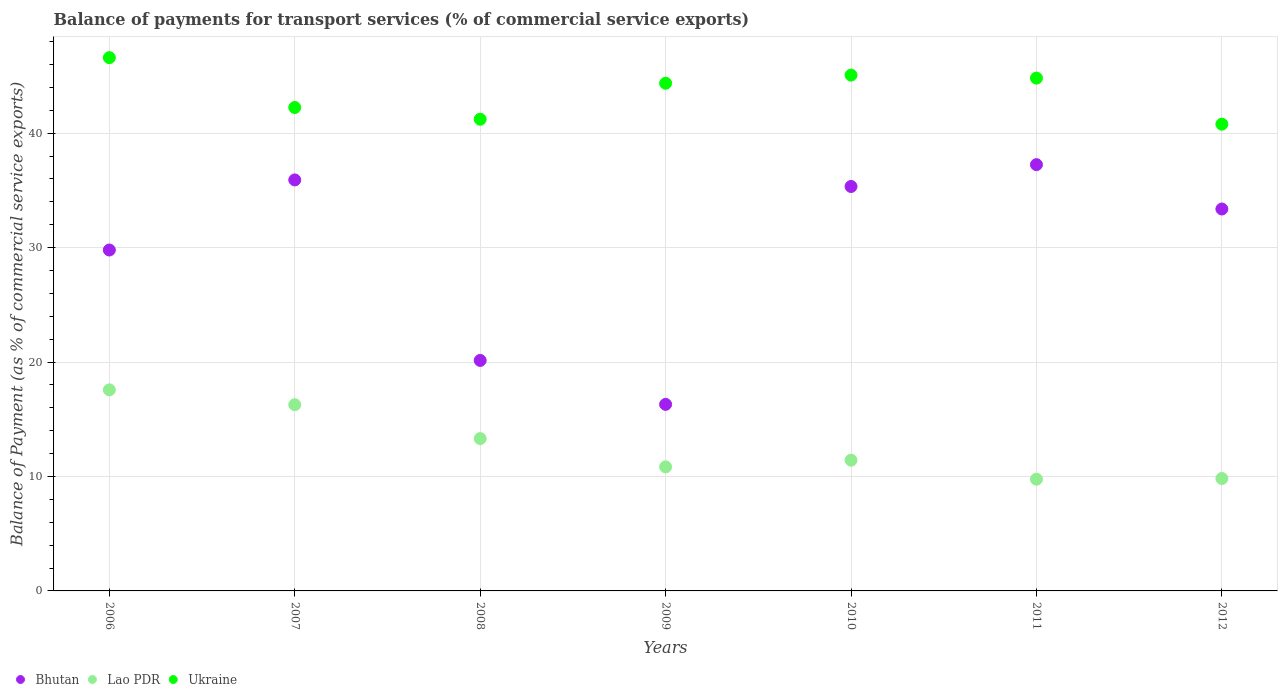Is the number of dotlines equal to the number of legend labels?
Provide a short and direct response. Yes. What is the balance of payments for transport services in Lao PDR in 2012?
Provide a short and direct response. 9.82. Across all years, what is the maximum balance of payments for transport services in Ukraine?
Provide a succinct answer. 46.6. Across all years, what is the minimum balance of payments for transport services in Ukraine?
Provide a short and direct response. 40.79. In which year was the balance of payments for transport services in Lao PDR maximum?
Make the answer very short. 2006. What is the total balance of payments for transport services in Ukraine in the graph?
Give a very brief answer. 305.09. What is the difference between the balance of payments for transport services in Ukraine in 2008 and that in 2009?
Your answer should be very brief. -3.15. What is the difference between the balance of payments for transport services in Ukraine in 2006 and the balance of payments for transport services in Lao PDR in 2009?
Provide a short and direct response. 35.76. What is the average balance of payments for transport services in Bhutan per year?
Your response must be concise. 29.73. In the year 2010, what is the difference between the balance of payments for transport services in Bhutan and balance of payments for transport services in Ukraine?
Provide a succinct answer. -9.73. What is the ratio of the balance of payments for transport services in Bhutan in 2006 to that in 2009?
Your answer should be compact. 1.83. Is the difference between the balance of payments for transport services in Bhutan in 2006 and 2010 greater than the difference between the balance of payments for transport services in Ukraine in 2006 and 2010?
Provide a succinct answer. No. What is the difference between the highest and the second highest balance of payments for transport services in Bhutan?
Give a very brief answer. 1.33. What is the difference between the highest and the lowest balance of payments for transport services in Bhutan?
Your response must be concise. 20.95. Is it the case that in every year, the sum of the balance of payments for transport services in Bhutan and balance of payments for transport services in Lao PDR  is greater than the balance of payments for transport services in Ukraine?
Offer a very short reply. No. What is the difference between two consecutive major ticks on the Y-axis?
Provide a short and direct response. 10. Does the graph contain grids?
Your response must be concise. Yes. How many legend labels are there?
Your response must be concise. 3. What is the title of the graph?
Your answer should be compact. Balance of payments for transport services (% of commercial service exports). Does "Fragile and conflict affected situations" appear as one of the legend labels in the graph?
Give a very brief answer. No. What is the label or title of the Y-axis?
Keep it short and to the point. Balance of Payment (as % of commercial service exports). What is the Balance of Payment (as % of commercial service exports) in Bhutan in 2006?
Make the answer very short. 29.79. What is the Balance of Payment (as % of commercial service exports) of Lao PDR in 2006?
Give a very brief answer. 17.57. What is the Balance of Payment (as % of commercial service exports) in Ukraine in 2006?
Your response must be concise. 46.6. What is the Balance of Payment (as % of commercial service exports) in Bhutan in 2007?
Offer a very short reply. 35.91. What is the Balance of Payment (as % of commercial service exports) of Lao PDR in 2007?
Give a very brief answer. 16.27. What is the Balance of Payment (as % of commercial service exports) of Ukraine in 2007?
Provide a short and direct response. 42.24. What is the Balance of Payment (as % of commercial service exports) of Bhutan in 2008?
Give a very brief answer. 20.14. What is the Balance of Payment (as % of commercial service exports) in Lao PDR in 2008?
Give a very brief answer. 13.31. What is the Balance of Payment (as % of commercial service exports) of Ukraine in 2008?
Offer a terse response. 41.22. What is the Balance of Payment (as % of commercial service exports) in Bhutan in 2009?
Your answer should be very brief. 16.3. What is the Balance of Payment (as % of commercial service exports) of Lao PDR in 2009?
Your answer should be very brief. 10.84. What is the Balance of Payment (as % of commercial service exports) of Ukraine in 2009?
Ensure brevity in your answer.  44.36. What is the Balance of Payment (as % of commercial service exports) of Bhutan in 2010?
Your response must be concise. 35.34. What is the Balance of Payment (as % of commercial service exports) of Lao PDR in 2010?
Ensure brevity in your answer.  11.42. What is the Balance of Payment (as % of commercial service exports) in Ukraine in 2010?
Your response must be concise. 45.07. What is the Balance of Payment (as % of commercial service exports) of Bhutan in 2011?
Offer a very short reply. 37.25. What is the Balance of Payment (as % of commercial service exports) of Lao PDR in 2011?
Your response must be concise. 9.76. What is the Balance of Payment (as % of commercial service exports) of Ukraine in 2011?
Keep it short and to the point. 44.81. What is the Balance of Payment (as % of commercial service exports) of Bhutan in 2012?
Your answer should be very brief. 33.37. What is the Balance of Payment (as % of commercial service exports) of Lao PDR in 2012?
Your response must be concise. 9.82. What is the Balance of Payment (as % of commercial service exports) in Ukraine in 2012?
Offer a terse response. 40.79. Across all years, what is the maximum Balance of Payment (as % of commercial service exports) of Bhutan?
Your answer should be compact. 37.25. Across all years, what is the maximum Balance of Payment (as % of commercial service exports) in Lao PDR?
Provide a short and direct response. 17.57. Across all years, what is the maximum Balance of Payment (as % of commercial service exports) of Ukraine?
Provide a succinct answer. 46.6. Across all years, what is the minimum Balance of Payment (as % of commercial service exports) of Bhutan?
Provide a succinct answer. 16.3. Across all years, what is the minimum Balance of Payment (as % of commercial service exports) of Lao PDR?
Provide a succinct answer. 9.76. Across all years, what is the minimum Balance of Payment (as % of commercial service exports) in Ukraine?
Ensure brevity in your answer.  40.79. What is the total Balance of Payment (as % of commercial service exports) in Bhutan in the graph?
Make the answer very short. 208.11. What is the total Balance of Payment (as % of commercial service exports) of Lao PDR in the graph?
Make the answer very short. 89. What is the total Balance of Payment (as % of commercial service exports) of Ukraine in the graph?
Make the answer very short. 305.09. What is the difference between the Balance of Payment (as % of commercial service exports) of Bhutan in 2006 and that in 2007?
Your answer should be very brief. -6.13. What is the difference between the Balance of Payment (as % of commercial service exports) of Lao PDR in 2006 and that in 2007?
Give a very brief answer. 1.3. What is the difference between the Balance of Payment (as % of commercial service exports) of Ukraine in 2006 and that in 2007?
Give a very brief answer. 4.36. What is the difference between the Balance of Payment (as % of commercial service exports) of Bhutan in 2006 and that in 2008?
Keep it short and to the point. 9.65. What is the difference between the Balance of Payment (as % of commercial service exports) of Lao PDR in 2006 and that in 2008?
Offer a very short reply. 4.26. What is the difference between the Balance of Payment (as % of commercial service exports) of Ukraine in 2006 and that in 2008?
Offer a very short reply. 5.38. What is the difference between the Balance of Payment (as % of commercial service exports) in Bhutan in 2006 and that in 2009?
Your answer should be compact. 13.49. What is the difference between the Balance of Payment (as % of commercial service exports) of Lao PDR in 2006 and that in 2009?
Your answer should be very brief. 6.73. What is the difference between the Balance of Payment (as % of commercial service exports) of Ukraine in 2006 and that in 2009?
Provide a succinct answer. 2.24. What is the difference between the Balance of Payment (as % of commercial service exports) in Bhutan in 2006 and that in 2010?
Your response must be concise. -5.55. What is the difference between the Balance of Payment (as % of commercial service exports) of Lao PDR in 2006 and that in 2010?
Offer a very short reply. 6.15. What is the difference between the Balance of Payment (as % of commercial service exports) in Ukraine in 2006 and that in 2010?
Give a very brief answer. 1.52. What is the difference between the Balance of Payment (as % of commercial service exports) of Bhutan in 2006 and that in 2011?
Your answer should be very brief. -7.46. What is the difference between the Balance of Payment (as % of commercial service exports) in Lao PDR in 2006 and that in 2011?
Provide a short and direct response. 7.81. What is the difference between the Balance of Payment (as % of commercial service exports) in Ukraine in 2006 and that in 2011?
Offer a terse response. 1.79. What is the difference between the Balance of Payment (as % of commercial service exports) of Bhutan in 2006 and that in 2012?
Provide a short and direct response. -3.58. What is the difference between the Balance of Payment (as % of commercial service exports) of Lao PDR in 2006 and that in 2012?
Provide a succinct answer. 7.75. What is the difference between the Balance of Payment (as % of commercial service exports) in Ukraine in 2006 and that in 2012?
Provide a short and direct response. 5.81. What is the difference between the Balance of Payment (as % of commercial service exports) of Bhutan in 2007 and that in 2008?
Keep it short and to the point. 15.77. What is the difference between the Balance of Payment (as % of commercial service exports) of Lao PDR in 2007 and that in 2008?
Your answer should be compact. 2.96. What is the difference between the Balance of Payment (as % of commercial service exports) of Ukraine in 2007 and that in 2008?
Provide a short and direct response. 1.03. What is the difference between the Balance of Payment (as % of commercial service exports) in Bhutan in 2007 and that in 2009?
Offer a terse response. 19.61. What is the difference between the Balance of Payment (as % of commercial service exports) in Lao PDR in 2007 and that in 2009?
Keep it short and to the point. 5.43. What is the difference between the Balance of Payment (as % of commercial service exports) in Ukraine in 2007 and that in 2009?
Offer a very short reply. -2.12. What is the difference between the Balance of Payment (as % of commercial service exports) in Bhutan in 2007 and that in 2010?
Your answer should be compact. 0.57. What is the difference between the Balance of Payment (as % of commercial service exports) in Lao PDR in 2007 and that in 2010?
Provide a succinct answer. 4.85. What is the difference between the Balance of Payment (as % of commercial service exports) of Ukraine in 2007 and that in 2010?
Give a very brief answer. -2.83. What is the difference between the Balance of Payment (as % of commercial service exports) in Bhutan in 2007 and that in 2011?
Keep it short and to the point. -1.33. What is the difference between the Balance of Payment (as % of commercial service exports) of Lao PDR in 2007 and that in 2011?
Provide a succinct answer. 6.51. What is the difference between the Balance of Payment (as % of commercial service exports) of Ukraine in 2007 and that in 2011?
Your response must be concise. -2.57. What is the difference between the Balance of Payment (as % of commercial service exports) in Bhutan in 2007 and that in 2012?
Make the answer very short. 2.54. What is the difference between the Balance of Payment (as % of commercial service exports) of Lao PDR in 2007 and that in 2012?
Offer a very short reply. 6.45. What is the difference between the Balance of Payment (as % of commercial service exports) of Ukraine in 2007 and that in 2012?
Make the answer very short. 1.46. What is the difference between the Balance of Payment (as % of commercial service exports) of Bhutan in 2008 and that in 2009?
Provide a short and direct response. 3.84. What is the difference between the Balance of Payment (as % of commercial service exports) in Lao PDR in 2008 and that in 2009?
Make the answer very short. 2.47. What is the difference between the Balance of Payment (as % of commercial service exports) in Ukraine in 2008 and that in 2009?
Ensure brevity in your answer.  -3.15. What is the difference between the Balance of Payment (as % of commercial service exports) of Bhutan in 2008 and that in 2010?
Provide a succinct answer. -15.2. What is the difference between the Balance of Payment (as % of commercial service exports) in Lao PDR in 2008 and that in 2010?
Provide a succinct answer. 1.89. What is the difference between the Balance of Payment (as % of commercial service exports) of Ukraine in 2008 and that in 2010?
Your answer should be very brief. -3.86. What is the difference between the Balance of Payment (as % of commercial service exports) of Bhutan in 2008 and that in 2011?
Your response must be concise. -17.11. What is the difference between the Balance of Payment (as % of commercial service exports) of Lao PDR in 2008 and that in 2011?
Your answer should be compact. 3.55. What is the difference between the Balance of Payment (as % of commercial service exports) of Ukraine in 2008 and that in 2011?
Keep it short and to the point. -3.59. What is the difference between the Balance of Payment (as % of commercial service exports) in Bhutan in 2008 and that in 2012?
Offer a very short reply. -13.23. What is the difference between the Balance of Payment (as % of commercial service exports) in Lao PDR in 2008 and that in 2012?
Make the answer very short. 3.49. What is the difference between the Balance of Payment (as % of commercial service exports) of Ukraine in 2008 and that in 2012?
Ensure brevity in your answer.  0.43. What is the difference between the Balance of Payment (as % of commercial service exports) in Bhutan in 2009 and that in 2010?
Make the answer very short. -19.04. What is the difference between the Balance of Payment (as % of commercial service exports) in Lao PDR in 2009 and that in 2010?
Your answer should be compact. -0.58. What is the difference between the Balance of Payment (as % of commercial service exports) of Ukraine in 2009 and that in 2010?
Provide a short and direct response. -0.71. What is the difference between the Balance of Payment (as % of commercial service exports) of Bhutan in 2009 and that in 2011?
Your response must be concise. -20.95. What is the difference between the Balance of Payment (as % of commercial service exports) of Lao PDR in 2009 and that in 2011?
Provide a short and direct response. 1.08. What is the difference between the Balance of Payment (as % of commercial service exports) of Ukraine in 2009 and that in 2011?
Your answer should be compact. -0.45. What is the difference between the Balance of Payment (as % of commercial service exports) in Bhutan in 2009 and that in 2012?
Your response must be concise. -17.07. What is the difference between the Balance of Payment (as % of commercial service exports) of Lao PDR in 2009 and that in 2012?
Ensure brevity in your answer.  1.02. What is the difference between the Balance of Payment (as % of commercial service exports) of Ukraine in 2009 and that in 2012?
Offer a terse response. 3.58. What is the difference between the Balance of Payment (as % of commercial service exports) in Bhutan in 2010 and that in 2011?
Your answer should be very brief. -1.91. What is the difference between the Balance of Payment (as % of commercial service exports) in Lao PDR in 2010 and that in 2011?
Provide a short and direct response. 1.66. What is the difference between the Balance of Payment (as % of commercial service exports) in Ukraine in 2010 and that in 2011?
Offer a very short reply. 0.26. What is the difference between the Balance of Payment (as % of commercial service exports) of Bhutan in 2010 and that in 2012?
Ensure brevity in your answer.  1.97. What is the difference between the Balance of Payment (as % of commercial service exports) of Lao PDR in 2010 and that in 2012?
Offer a very short reply. 1.6. What is the difference between the Balance of Payment (as % of commercial service exports) in Ukraine in 2010 and that in 2012?
Your response must be concise. 4.29. What is the difference between the Balance of Payment (as % of commercial service exports) in Bhutan in 2011 and that in 2012?
Make the answer very short. 3.88. What is the difference between the Balance of Payment (as % of commercial service exports) of Lao PDR in 2011 and that in 2012?
Provide a short and direct response. -0.06. What is the difference between the Balance of Payment (as % of commercial service exports) of Ukraine in 2011 and that in 2012?
Keep it short and to the point. 4.03. What is the difference between the Balance of Payment (as % of commercial service exports) in Bhutan in 2006 and the Balance of Payment (as % of commercial service exports) in Lao PDR in 2007?
Provide a succinct answer. 13.52. What is the difference between the Balance of Payment (as % of commercial service exports) in Bhutan in 2006 and the Balance of Payment (as % of commercial service exports) in Ukraine in 2007?
Provide a succinct answer. -12.45. What is the difference between the Balance of Payment (as % of commercial service exports) in Lao PDR in 2006 and the Balance of Payment (as % of commercial service exports) in Ukraine in 2007?
Provide a succinct answer. -24.67. What is the difference between the Balance of Payment (as % of commercial service exports) in Bhutan in 2006 and the Balance of Payment (as % of commercial service exports) in Lao PDR in 2008?
Keep it short and to the point. 16.48. What is the difference between the Balance of Payment (as % of commercial service exports) in Bhutan in 2006 and the Balance of Payment (as % of commercial service exports) in Ukraine in 2008?
Make the answer very short. -11.43. What is the difference between the Balance of Payment (as % of commercial service exports) in Lao PDR in 2006 and the Balance of Payment (as % of commercial service exports) in Ukraine in 2008?
Provide a succinct answer. -23.65. What is the difference between the Balance of Payment (as % of commercial service exports) in Bhutan in 2006 and the Balance of Payment (as % of commercial service exports) in Lao PDR in 2009?
Offer a very short reply. 18.95. What is the difference between the Balance of Payment (as % of commercial service exports) of Bhutan in 2006 and the Balance of Payment (as % of commercial service exports) of Ukraine in 2009?
Offer a very short reply. -14.57. What is the difference between the Balance of Payment (as % of commercial service exports) of Lao PDR in 2006 and the Balance of Payment (as % of commercial service exports) of Ukraine in 2009?
Ensure brevity in your answer.  -26.79. What is the difference between the Balance of Payment (as % of commercial service exports) of Bhutan in 2006 and the Balance of Payment (as % of commercial service exports) of Lao PDR in 2010?
Provide a succinct answer. 18.36. What is the difference between the Balance of Payment (as % of commercial service exports) of Bhutan in 2006 and the Balance of Payment (as % of commercial service exports) of Ukraine in 2010?
Give a very brief answer. -15.28. What is the difference between the Balance of Payment (as % of commercial service exports) of Lao PDR in 2006 and the Balance of Payment (as % of commercial service exports) of Ukraine in 2010?
Offer a terse response. -27.5. What is the difference between the Balance of Payment (as % of commercial service exports) in Bhutan in 2006 and the Balance of Payment (as % of commercial service exports) in Lao PDR in 2011?
Give a very brief answer. 20.03. What is the difference between the Balance of Payment (as % of commercial service exports) of Bhutan in 2006 and the Balance of Payment (as % of commercial service exports) of Ukraine in 2011?
Provide a short and direct response. -15.02. What is the difference between the Balance of Payment (as % of commercial service exports) in Lao PDR in 2006 and the Balance of Payment (as % of commercial service exports) in Ukraine in 2011?
Your response must be concise. -27.24. What is the difference between the Balance of Payment (as % of commercial service exports) in Bhutan in 2006 and the Balance of Payment (as % of commercial service exports) in Lao PDR in 2012?
Provide a short and direct response. 19.97. What is the difference between the Balance of Payment (as % of commercial service exports) of Bhutan in 2006 and the Balance of Payment (as % of commercial service exports) of Ukraine in 2012?
Offer a very short reply. -11. What is the difference between the Balance of Payment (as % of commercial service exports) of Lao PDR in 2006 and the Balance of Payment (as % of commercial service exports) of Ukraine in 2012?
Give a very brief answer. -23.22. What is the difference between the Balance of Payment (as % of commercial service exports) in Bhutan in 2007 and the Balance of Payment (as % of commercial service exports) in Lao PDR in 2008?
Provide a succinct answer. 22.6. What is the difference between the Balance of Payment (as % of commercial service exports) of Bhutan in 2007 and the Balance of Payment (as % of commercial service exports) of Ukraine in 2008?
Provide a succinct answer. -5.3. What is the difference between the Balance of Payment (as % of commercial service exports) in Lao PDR in 2007 and the Balance of Payment (as % of commercial service exports) in Ukraine in 2008?
Your response must be concise. -24.94. What is the difference between the Balance of Payment (as % of commercial service exports) of Bhutan in 2007 and the Balance of Payment (as % of commercial service exports) of Lao PDR in 2009?
Make the answer very short. 25.07. What is the difference between the Balance of Payment (as % of commercial service exports) in Bhutan in 2007 and the Balance of Payment (as % of commercial service exports) in Ukraine in 2009?
Provide a succinct answer. -8.45. What is the difference between the Balance of Payment (as % of commercial service exports) of Lao PDR in 2007 and the Balance of Payment (as % of commercial service exports) of Ukraine in 2009?
Ensure brevity in your answer.  -28.09. What is the difference between the Balance of Payment (as % of commercial service exports) of Bhutan in 2007 and the Balance of Payment (as % of commercial service exports) of Lao PDR in 2010?
Keep it short and to the point. 24.49. What is the difference between the Balance of Payment (as % of commercial service exports) of Bhutan in 2007 and the Balance of Payment (as % of commercial service exports) of Ukraine in 2010?
Your response must be concise. -9.16. What is the difference between the Balance of Payment (as % of commercial service exports) of Lao PDR in 2007 and the Balance of Payment (as % of commercial service exports) of Ukraine in 2010?
Keep it short and to the point. -28.8. What is the difference between the Balance of Payment (as % of commercial service exports) of Bhutan in 2007 and the Balance of Payment (as % of commercial service exports) of Lao PDR in 2011?
Make the answer very short. 26.15. What is the difference between the Balance of Payment (as % of commercial service exports) in Bhutan in 2007 and the Balance of Payment (as % of commercial service exports) in Ukraine in 2011?
Offer a very short reply. -8.9. What is the difference between the Balance of Payment (as % of commercial service exports) in Lao PDR in 2007 and the Balance of Payment (as % of commercial service exports) in Ukraine in 2011?
Give a very brief answer. -28.54. What is the difference between the Balance of Payment (as % of commercial service exports) of Bhutan in 2007 and the Balance of Payment (as % of commercial service exports) of Lao PDR in 2012?
Ensure brevity in your answer.  26.09. What is the difference between the Balance of Payment (as % of commercial service exports) of Bhutan in 2007 and the Balance of Payment (as % of commercial service exports) of Ukraine in 2012?
Offer a very short reply. -4.87. What is the difference between the Balance of Payment (as % of commercial service exports) in Lao PDR in 2007 and the Balance of Payment (as % of commercial service exports) in Ukraine in 2012?
Provide a short and direct response. -24.51. What is the difference between the Balance of Payment (as % of commercial service exports) in Bhutan in 2008 and the Balance of Payment (as % of commercial service exports) in Lao PDR in 2009?
Ensure brevity in your answer.  9.3. What is the difference between the Balance of Payment (as % of commercial service exports) of Bhutan in 2008 and the Balance of Payment (as % of commercial service exports) of Ukraine in 2009?
Offer a very short reply. -24.22. What is the difference between the Balance of Payment (as % of commercial service exports) in Lao PDR in 2008 and the Balance of Payment (as % of commercial service exports) in Ukraine in 2009?
Keep it short and to the point. -31.05. What is the difference between the Balance of Payment (as % of commercial service exports) of Bhutan in 2008 and the Balance of Payment (as % of commercial service exports) of Lao PDR in 2010?
Provide a succinct answer. 8.72. What is the difference between the Balance of Payment (as % of commercial service exports) in Bhutan in 2008 and the Balance of Payment (as % of commercial service exports) in Ukraine in 2010?
Provide a succinct answer. -24.93. What is the difference between the Balance of Payment (as % of commercial service exports) in Lao PDR in 2008 and the Balance of Payment (as % of commercial service exports) in Ukraine in 2010?
Keep it short and to the point. -31.76. What is the difference between the Balance of Payment (as % of commercial service exports) of Bhutan in 2008 and the Balance of Payment (as % of commercial service exports) of Lao PDR in 2011?
Offer a terse response. 10.38. What is the difference between the Balance of Payment (as % of commercial service exports) of Bhutan in 2008 and the Balance of Payment (as % of commercial service exports) of Ukraine in 2011?
Make the answer very short. -24.67. What is the difference between the Balance of Payment (as % of commercial service exports) in Lao PDR in 2008 and the Balance of Payment (as % of commercial service exports) in Ukraine in 2011?
Give a very brief answer. -31.5. What is the difference between the Balance of Payment (as % of commercial service exports) of Bhutan in 2008 and the Balance of Payment (as % of commercial service exports) of Lao PDR in 2012?
Your answer should be compact. 10.32. What is the difference between the Balance of Payment (as % of commercial service exports) of Bhutan in 2008 and the Balance of Payment (as % of commercial service exports) of Ukraine in 2012?
Your response must be concise. -20.65. What is the difference between the Balance of Payment (as % of commercial service exports) in Lao PDR in 2008 and the Balance of Payment (as % of commercial service exports) in Ukraine in 2012?
Your answer should be compact. -27.47. What is the difference between the Balance of Payment (as % of commercial service exports) of Bhutan in 2009 and the Balance of Payment (as % of commercial service exports) of Lao PDR in 2010?
Your response must be concise. 4.88. What is the difference between the Balance of Payment (as % of commercial service exports) of Bhutan in 2009 and the Balance of Payment (as % of commercial service exports) of Ukraine in 2010?
Give a very brief answer. -28.77. What is the difference between the Balance of Payment (as % of commercial service exports) in Lao PDR in 2009 and the Balance of Payment (as % of commercial service exports) in Ukraine in 2010?
Give a very brief answer. -34.23. What is the difference between the Balance of Payment (as % of commercial service exports) in Bhutan in 2009 and the Balance of Payment (as % of commercial service exports) in Lao PDR in 2011?
Offer a terse response. 6.54. What is the difference between the Balance of Payment (as % of commercial service exports) of Bhutan in 2009 and the Balance of Payment (as % of commercial service exports) of Ukraine in 2011?
Provide a succinct answer. -28.51. What is the difference between the Balance of Payment (as % of commercial service exports) of Lao PDR in 2009 and the Balance of Payment (as % of commercial service exports) of Ukraine in 2011?
Make the answer very short. -33.97. What is the difference between the Balance of Payment (as % of commercial service exports) of Bhutan in 2009 and the Balance of Payment (as % of commercial service exports) of Lao PDR in 2012?
Offer a terse response. 6.48. What is the difference between the Balance of Payment (as % of commercial service exports) in Bhutan in 2009 and the Balance of Payment (as % of commercial service exports) in Ukraine in 2012?
Give a very brief answer. -24.48. What is the difference between the Balance of Payment (as % of commercial service exports) in Lao PDR in 2009 and the Balance of Payment (as % of commercial service exports) in Ukraine in 2012?
Provide a succinct answer. -29.95. What is the difference between the Balance of Payment (as % of commercial service exports) in Bhutan in 2010 and the Balance of Payment (as % of commercial service exports) in Lao PDR in 2011?
Make the answer very short. 25.58. What is the difference between the Balance of Payment (as % of commercial service exports) in Bhutan in 2010 and the Balance of Payment (as % of commercial service exports) in Ukraine in 2011?
Provide a short and direct response. -9.47. What is the difference between the Balance of Payment (as % of commercial service exports) in Lao PDR in 2010 and the Balance of Payment (as % of commercial service exports) in Ukraine in 2011?
Offer a terse response. -33.39. What is the difference between the Balance of Payment (as % of commercial service exports) in Bhutan in 2010 and the Balance of Payment (as % of commercial service exports) in Lao PDR in 2012?
Keep it short and to the point. 25.52. What is the difference between the Balance of Payment (as % of commercial service exports) of Bhutan in 2010 and the Balance of Payment (as % of commercial service exports) of Ukraine in 2012?
Ensure brevity in your answer.  -5.44. What is the difference between the Balance of Payment (as % of commercial service exports) of Lao PDR in 2010 and the Balance of Payment (as % of commercial service exports) of Ukraine in 2012?
Offer a terse response. -29.36. What is the difference between the Balance of Payment (as % of commercial service exports) in Bhutan in 2011 and the Balance of Payment (as % of commercial service exports) in Lao PDR in 2012?
Your answer should be compact. 27.43. What is the difference between the Balance of Payment (as % of commercial service exports) of Bhutan in 2011 and the Balance of Payment (as % of commercial service exports) of Ukraine in 2012?
Your answer should be compact. -3.54. What is the difference between the Balance of Payment (as % of commercial service exports) of Lao PDR in 2011 and the Balance of Payment (as % of commercial service exports) of Ukraine in 2012?
Make the answer very short. -31.02. What is the average Balance of Payment (as % of commercial service exports) in Bhutan per year?
Offer a terse response. 29.73. What is the average Balance of Payment (as % of commercial service exports) of Lao PDR per year?
Offer a terse response. 12.71. What is the average Balance of Payment (as % of commercial service exports) of Ukraine per year?
Provide a short and direct response. 43.58. In the year 2006, what is the difference between the Balance of Payment (as % of commercial service exports) of Bhutan and Balance of Payment (as % of commercial service exports) of Lao PDR?
Offer a very short reply. 12.22. In the year 2006, what is the difference between the Balance of Payment (as % of commercial service exports) in Bhutan and Balance of Payment (as % of commercial service exports) in Ukraine?
Give a very brief answer. -16.81. In the year 2006, what is the difference between the Balance of Payment (as % of commercial service exports) in Lao PDR and Balance of Payment (as % of commercial service exports) in Ukraine?
Your response must be concise. -29.03. In the year 2007, what is the difference between the Balance of Payment (as % of commercial service exports) of Bhutan and Balance of Payment (as % of commercial service exports) of Lao PDR?
Make the answer very short. 19.64. In the year 2007, what is the difference between the Balance of Payment (as % of commercial service exports) of Bhutan and Balance of Payment (as % of commercial service exports) of Ukraine?
Give a very brief answer. -6.33. In the year 2007, what is the difference between the Balance of Payment (as % of commercial service exports) of Lao PDR and Balance of Payment (as % of commercial service exports) of Ukraine?
Your answer should be very brief. -25.97. In the year 2008, what is the difference between the Balance of Payment (as % of commercial service exports) in Bhutan and Balance of Payment (as % of commercial service exports) in Lao PDR?
Ensure brevity in your answer.  6.83. In the year 2008, what is the difference between the Balance of Payment (as % of commercial service exports) in Bhutan and Balance of Payment (as % of commercial service exports) in Ukraine?
Make the answer very short. -21.08. In the year 2008, what is the difference between the Balance of Payment (as % of commercial service exports) of Lao PDR and Balance of Payment (as % of commercial service exports) of Ukraine?
Make the answer very short. -27.9. In the year 2009, what is the difference between the Balance of Payment (as % of commercial service exports) of Bhutan and Balance of Payment (as % of commercial service exports) of Lao PDR?
Offer a very short reply. 5.46. In the year 2009, what is the difference between the Balance of Payment (as % of commercial service exports) in Bhutan and Balance of Payment (as % of commercial service exports) in Ukraine?
Keep it short and to the point. -28.06. In the year 2009, what is the difference between the Balance of Payment (as % of commercial service exports) in Lao PDR and Balance of Payment (as % of commercial service exports) in Ukraine?
Offer a very short reply. -33.52. In the year 2010, what is the difference between the Balance of Payment (as % of commercial service exports) of Bhutan and Balance of Payment (as % of commercial service exports) of Lao PDR?
Give a very brief answer. 23.92. In the year 2010, what is the difference between the Balance of Payment (as % of commercial service exports) of Bhutan and Balance of Payment (as % of commercial service exports) of Ukraine?
Offer a terse response. -9.73. In the year 2010, what is the difference between the Balance of Payment (as % of commercial service exports) in Lao PDR and Balance of Payment (as % of commercial service exports) in Ukraine?
Your answer should be very brief. -33.65. In the year 2011, what is the difference between the Balance of Payment (as % of commercial service exports) in Bhutan and Balance of Payment (as % of commercial service exports) in Lao PDR?
Offer a terse response. 27.49. In the year 2011, what is the difference between the Balance of Payment (as % of commercial service exports) in Bhutan and Balance of Payment (as % of commercial service exports) in Ukraine?
Ensure brevity in your answer.  -7.56. In the year 2011, what is the difference between the Balance of Payment (as % of commercial service exports) in Lao PDR and Balance of Payment (as % of commercial service exports) in Ukraine?
Make the answer very short. -35.05. In the year 2012, what is the difference between the Balance of Payment (as % of commercial service exports) of Bhutan and Balance of Payment (as % of commercial service exports) of Lao PDR?
Your answer should be compact. 23.55. In the year 2012, what is the difference between the Balance of Payment (as % of commercial service exports) of Bhutan and Balance of Payment (as % of commercial service exports) of Ukraine?
Offer a terse response. -7.41. In the year 2012, what is the difference between the Balance of Payment (as % of commercial service exports) in Lao PDR and Balance of Payment (as % of commercial service exports) in Ukraine?
Provide a short and direct response. -30.96. What is the ratio of the Balance of Payment (as % of commercial service exports) of Bhutan in 2006 to that in 2007?
Make the answer very short. 0.83. What is the ratio of the Balance of Payment (as % of commercial service exports) of Lao PDR in 2006 to that in 2007?
Ensure brevity in your answer.  1.08. What is the ratio of the Balance of Payment (as % of commercial service exports) in Ukraine in 2006 to that in 2007?
Provide a succinct answer. 1.1. What is the ratio of the Balance of Payment (as % of commercial service exports) of Bhutan in 2006 to that in 2008?
Make the answer very short. 1.48. What is the ratio of the Balance of Payment (as % of commercial service exports) in Lao PDR in 2006 to that in 2008?
Provide a short and direct response. 1.32. What is the ratio of the Balance of Payment (as % of commercial service exports) of Ukraine in 2006 to that in 2008?
Ensure brevity in your answer.  1.13. What is the ratio of the Balance of Payment (as % of commercial service exports) in Bhutan in 2006 to that in 2009?
Keep it short and to the point. 1.83. What is the ratio of the Balance of Payment (as % of commercial service exports) in Lao PDR in 2006 to that in 2009?
Your response must be concise. 1.62. What is the ratio of the Balance of Payment (as % of commercial service exports) in Ukraine in 2006 to that in 2009?
Offer a terse response. 1.05. What is the ratio of the Balance of Payment (as % of commercial service exports) in Bhutan in 2006 to that in 2010?
Offer a terse response. 0.84. What is the ratio of the Balance of Payment (as % of commercial service exports) in Lao PDR in 2006 to that in 2010?
Offer a very short reply. 1.54. What is the ratio of the Balance of Payment (as % of commercial service exports) in Ukraine in 2006 to that in 2010?
Provide a short and direct response. 1.03. What is the ratio of the Balance of Payment (as % of commercial service exports) of Bhutan in 2006 to that in 2011?
Your answer should be very brief. 0.8. What is the ratio of the Balance of Payment (as % of commercial service exports) of Lao PDR in 2006 to that in 2011?
Offer a very short reply. 1.8. What is the ratio of the Balance of Payment (as % of commercial service exports) in Ukraine in 2006 to that in 2011?
Offer a very short reply. 1.04. What is the ratio of the Balance of Payment (as % of commercial service exports) in Bhutan in 2006 to that in 2012?
Your answer should be compact. 0.89. What is the ratio of the Balance of Payment (as % of commercial service exports) in Lao PDR in 2006 to that in 2012?
Ensure brevity in your answer.  1.79. What is the ratio of the Balance of Payment (as % of commercial service exports) of Ukraine in 2006 to that in 2012?
Provide a succinct answer. 1.14. What is the ratio of the Balance of Payment (as % of commercial service exports) of Bhutan in 2007 to that in 2008?
Keep it short and to the point. 1.78. What is the ratio of the Balance of Payment (as % of commercial service exports) of Lao PDR in 2007 to that in 2008?
Offer a very short reply. 1.22. What is the ratio of the Balance of Payment (as % of commercial service exports) in Ukraine in 2007 to that in 2008?
Offer a terse response. 1.02. What is the ratio of the Balance of Payment (as % of commercial service exports) of Bhutan in 2007 to that in 2009?
Your response must be concise. 2.2. What is the ratio of the Balance of Payment (as % of commercial service exports) of Lao PDR in 2007 to that in 2009?
Offer a terse response. 1.5. What is the ratio of the Balance of Payment (as % of commercial service exports) in Ukraine in 2007 to that in 2009?
Provide a succinct answer. 0.95. What is the ratio of the Balance of Payment (as % of commercial service exports) of Bhutan in 2007 to that in 2010?
Provide a succinct answer. 1.02. What is the ratio of the Balance of Payment (as % of commercial service exports) in Lao PDR in 2007 to that in 2010?
Keep it short and to the point. 1.42. What is the ratio of the Balance of Payment (as % of commercial service exports) of Ukraine in 2007 to that in 2010?
Offer a terse response. 0.94. What is the ratio of the Balance of Payment (as % of commercial service exports) of Bhutan in 2007 to that in 2011?
Make the answer very short. 0.96. What is the ratio of the Balance of Payment (as % of commercial service exports) in Lao PDR in 2007 to that in 2011?
Your response must be concise. 1.67. What is the ratio of the Balance of Payment (as % of commercial service exports) in Ukraine in 2007 to that in 2011?
Keep it short and to the point. 0.94. What is the ratio of the Balance of Payment (as % of commercial service exports) in Bhutan in 2007 to that in 2012?
Offer a very short reply. 1.08. What is the ratio of the Balance of Payment (as % of commercial service exports) of Lao PDR in 2007 to that in 2012?
Offer a terse response. 1.66. What is the ratio of the Balance of Payment (as % of commercial service exports) in Ukraine in 2007 to that in 2012?
Offer a very short reply. 1.04. What is the ratio of the Balance of Payment (as % of commercial service exports) in Bhutan in 2008 to that in 2009?
Keep it short and to the point. 1.24. What is the ratio of the Balance of Payment (as % of commercial service exports) in Lao PDR in 2008 to that in 2009?
Provide a short and direct response. 1.23. What is the ratio of the Balance of Payment (as % of commercial service exports) in Ukraine in 2008 to that in 2009?
Keep it short and to the point. 0.93. What is the ratio of the Balance of Payment (as % of commercial service exports) of Bhutan in 2008 to that in 2010?
Keep it short and to the point. 0.57. What is the ratio of the Balance of Payment (as % of commercial service exports) in Lao PDR in 2008 to that in 2010?
Offer a very short reply. 1.17. What is the ratio of the Balance of Payment (as % of commercial service exports) in Ukraine in 2008 to that in 2010?
Your response must be concise. 0.91. What is the ratio of the Balance of Payment (as % of commercial service exports) of Bhutan in 2008 to that in 2011?
Your answer should be compact. 0.54. What is the ratio of the Balance of Payment (as % of commercial service exports) of Lao PDR in 2008 to that in 2011?
Ensure brevity in your answer.  1.36. What is the ratio of the Balance of Payment (as % of commercial service exports) of Ukraine in 2008 to that in 2011?
Offer a terse response. 0.92. What is the ratio of the Balance of Payment (as % of commercial service exports) in Bhutan in 2008 to that in 2012?
Make the answer very short. 0.6. What is the ratio of the Balance of Payment (as % of commercial service exports) in Lao PDR in 2008 to that in 2012?
Keep it short and to the point. 1.36. What is the ratio of the Balance of Payment (as % of commercial service exports) of Ukraine in 2008 to that in 2012?
Provide a short and direct response. 1.01. What is the ratio of the Balance of Payment (as % of commercial service exports) of Bhutan in 2009 to that in 2010?
Offer a terse response. 0.46. What is the ratio of the Balance of Payment (as % of commercial service exports) of Lao PDR in 2009 to that in 2010?
Your response must be concise. 0.95. What is the ratio of the Balance of Payment (as % of commercial service exports) in Ukraine in 2009 to that in 2010?
Your response must be concise. 0.98. What is the ratio of the Balance of Payment (as % of commercial service exports) of Bhutan in 2009 to that in 2011?
Your answer should be very brief. 0.44. What is the ratio of the Balance of Payment (as % of commercial service exports) in Lao PDR in 2009 to that in 2011?
Offer a terse response. 1.11. What is the ratio of the Balance of Payment (as % of commercial service exports) in Ukraine in 2009 to that in 2011?
Your answer should be very brief. 0.99. What is the ratio of the Balance of Payment (as % of commercial service exports) in Bhutan in 2009 to that in 2012?
Your response must be concise. 0.49. What is the ratio of the Balance of Payment (as % of commercial service exports) in Lao PDR in 2009 to that in 2012?
Give a very brief answer. 1.1. What is the ratio of the Balance of Payment (as % of commercial service exports) in Ukraine in 2009 to that in 2012?
Offer a very short reply. 1.09. What is the ratio of the Balance of Payment (as % of commercial service exports) in Bhutan in 2010 to that in 2011?
Your answer should be very brief. 0.95. What is the ratio of the Balance of Payment (as % of commercial service exports) of Lao PDR in 2010 to that in 2011?
Give a very brief answer. 1.17. What is the ratio of the Balance of Payment (as % of commercial service exports) of Ukraine in 2010 to that in 2011?
Give a very brief answer. 1.01. What is the ratio of the Balance of Payment (as % of commercial service exports) in Bhutan in 2010 to that in 2012?
Give a very brief answer. 1.06. What is the ratio of the Balance of Payment (as % of commercial service exports) in Lao PDR in 2010 to that in 2012?
Your answer should be very brief. 1.16. What is the ratio of the Balance of Payment (as % of commercial service exports) in Ukraine in 2010 to that in 2012?
Provide a succinct answer. 1.11. What is the ratio of the Balance of Payment (as % of commercial service exports) in Bhutan in 2011 to that in 2012?
Ensure brevity in your answer.  1.12. What is the ratio of the Balance of Payment (as % of commercial service exports) in Lao PDR in 2011 to that in 2012?
Ensure brevity in your answer.  0.99. What is the ratio of the Balance of Payment (as % of commercial service exports) of Ukraine in 2011 to that in 2012?
Provide a short and direct response. 1.1. What is the difference between the highest and the second highest Balance of Payment (as % of commercial service exports) in Bhutan?
Make the answer very short. 1.33. What is the difference between the highest and the second highest Balance of Payment (as % of commercial service exports) in Lao PDR?
Your answer should be very brief. 1.3. What is the difference between the highest and the second highest Balance of Payment (as % of commercial service exports) of Ukraine?
Offer a very short reply. 1.52. What is the difference between the highest and the lowest Balance of Payment (as % of commercial service exports) of Bhutan?
Your response must be concise. 20.95. What is the difference between the highest and the lowest Balance of Payment (as % of commercial service exports) in Lao PDR?
Make the answer very short. 7.81. What is the difference between the highest and the lowest Balance of Payment (as % of commercial service exports) of Ukraine?
Offer a very short reply. 5.81. 